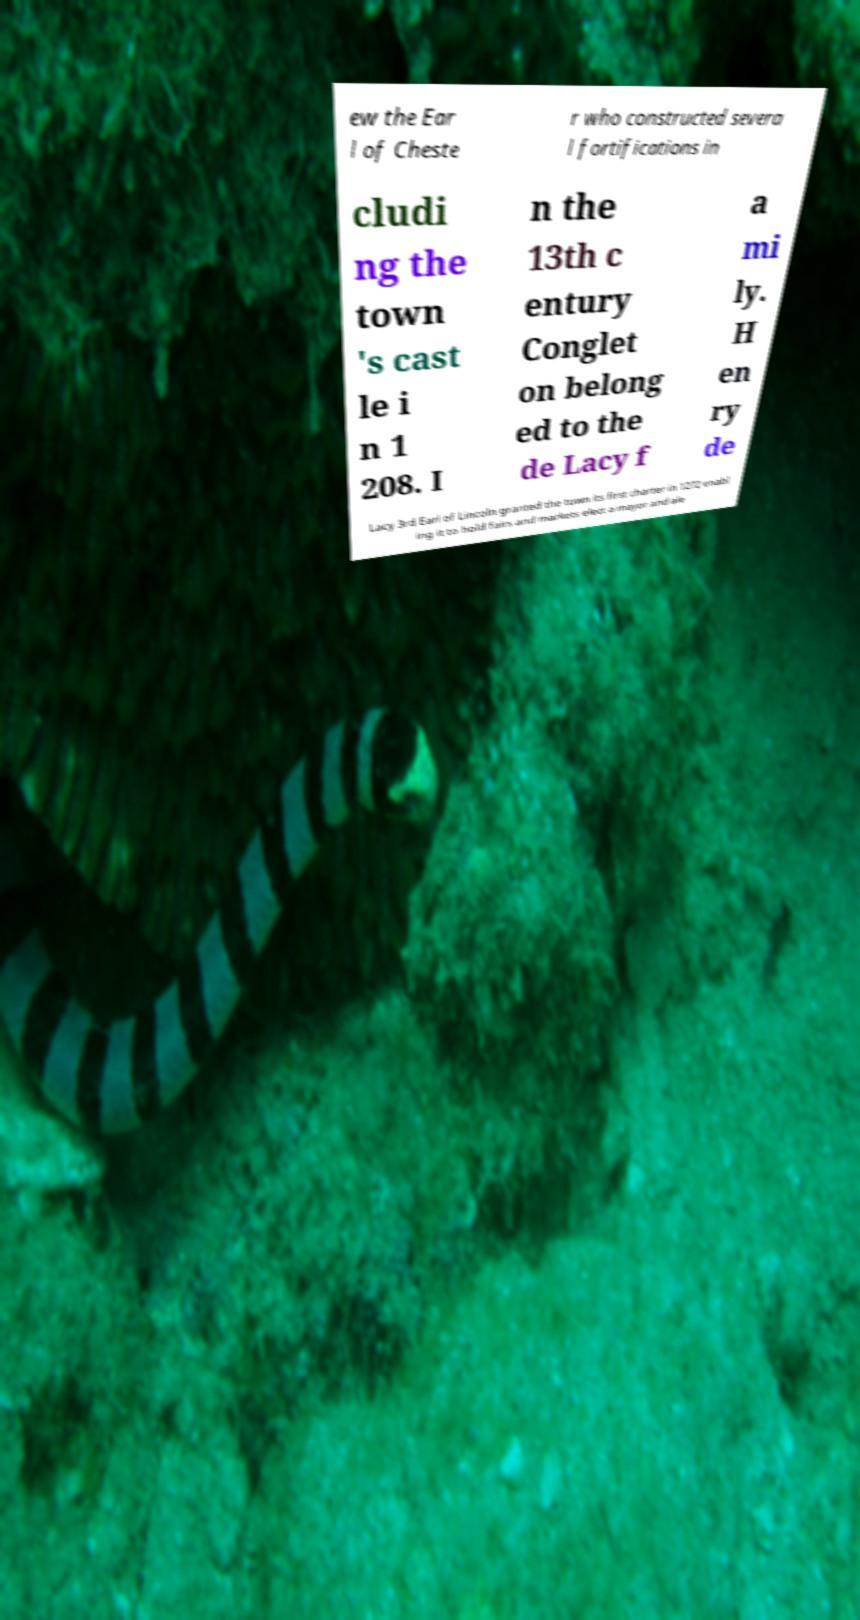Could you extract and type out the text from this image? ew the Ear l of Cheste r who constructed severa l fortifications in cludi ng the town 's cast le i n 1 208. I n the 13th c entury Conglet on belong ed to the de Lacy f a mi ly. H en ry de Lacy 3rd Earl of Lincoln granted the town its first charter in 1272 enabl ing it to hold fairs and markets elect a mayor and ale 